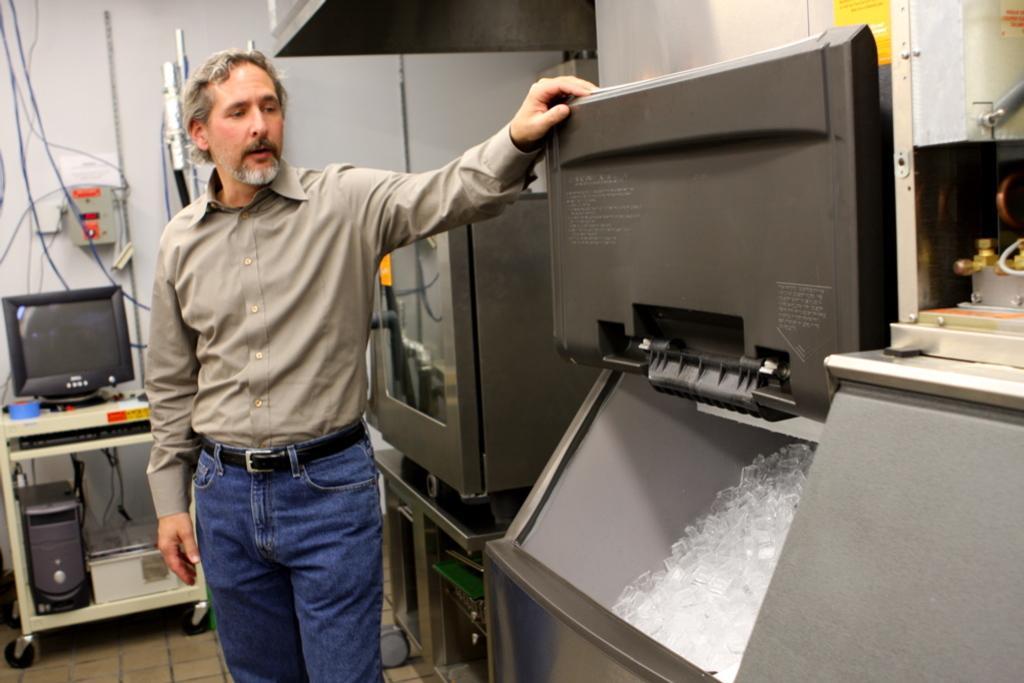Could you give a brief overview of what you see in this image? In this picture we can see a person, here we can see monitors, CPU, wall and some objects. 